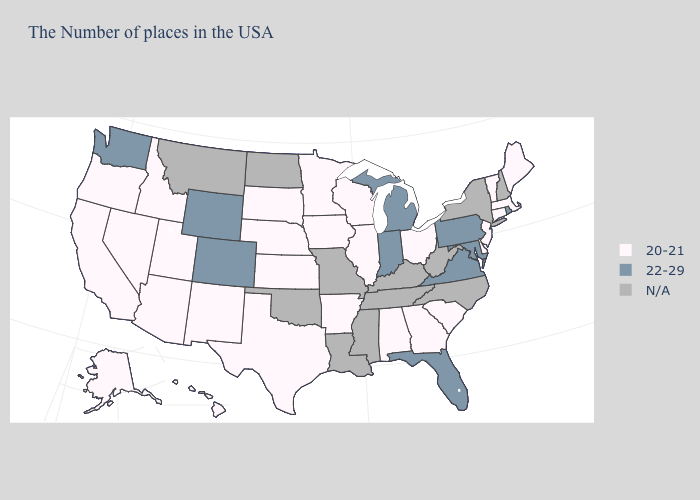What is the lowest value in the MidWest?
Write a very short answer. 20-21. Name the states that have a value in the range 22-29?
Be succinct. Rhode Island, Maryland, Pennsylvania, Virginia, Florida, Michigan, Indiana, Wyoming, Colorado, Washington. How many symbols are there in the legend?
Short answer required. 3. What is the lowest value in states that border Missouri?
Be succinct. 20-21. What is the value of New York?
Be succinct. N/A. Does Virginia have the highest value in the USA?
Concise answer only. Yes. Does Pennsylvania have the lowest value in the USA?
Answer briefly. No. Among the states that border New Jersey , does Delaware have the lowest value?
Write a very short answer. Yes. What is the value of Ohio?
Write a very short answer. 20-21. Does Pennsylvania have the lowest value in the Northeast?
Answer briefly. No. What is the value of Wisconsin?
Keep it brief. 20-21. What is the lowest value in the USA?
Be succinct. 20-21. What is the value of North Carolina?
Answer briefly. N/A. 